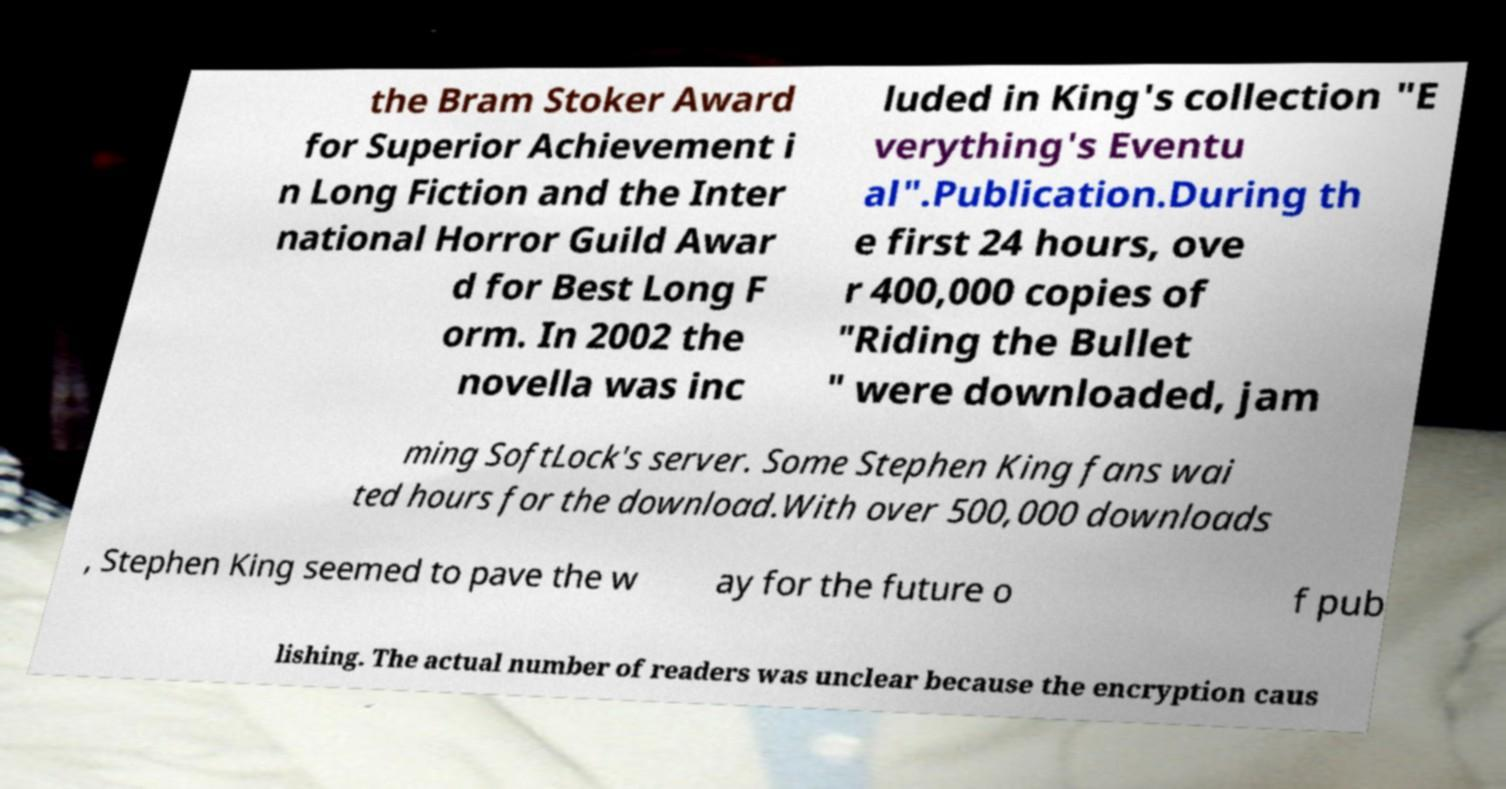Please identify and transcribe the text found in this image. the Bram Stoker Award for Superior Achievement i n Long Fiction and the Inter national Horror Guild Awar d for Best Long F orm. In 2002 the novella was inc luded in King's collection "E verything's Eventu al".Publication.During th e first 24 hours, ove r 400,000 copies of "Riding the Bullet " were downloaded, jam ming SoftLock's server. Some Stephen King fans wai ted hours for the download.With over 500,000 downloads , Stephen King seemed to pave the w ay for the future o f pub lishing. The actual number of readers was unclear because the encryption caus 